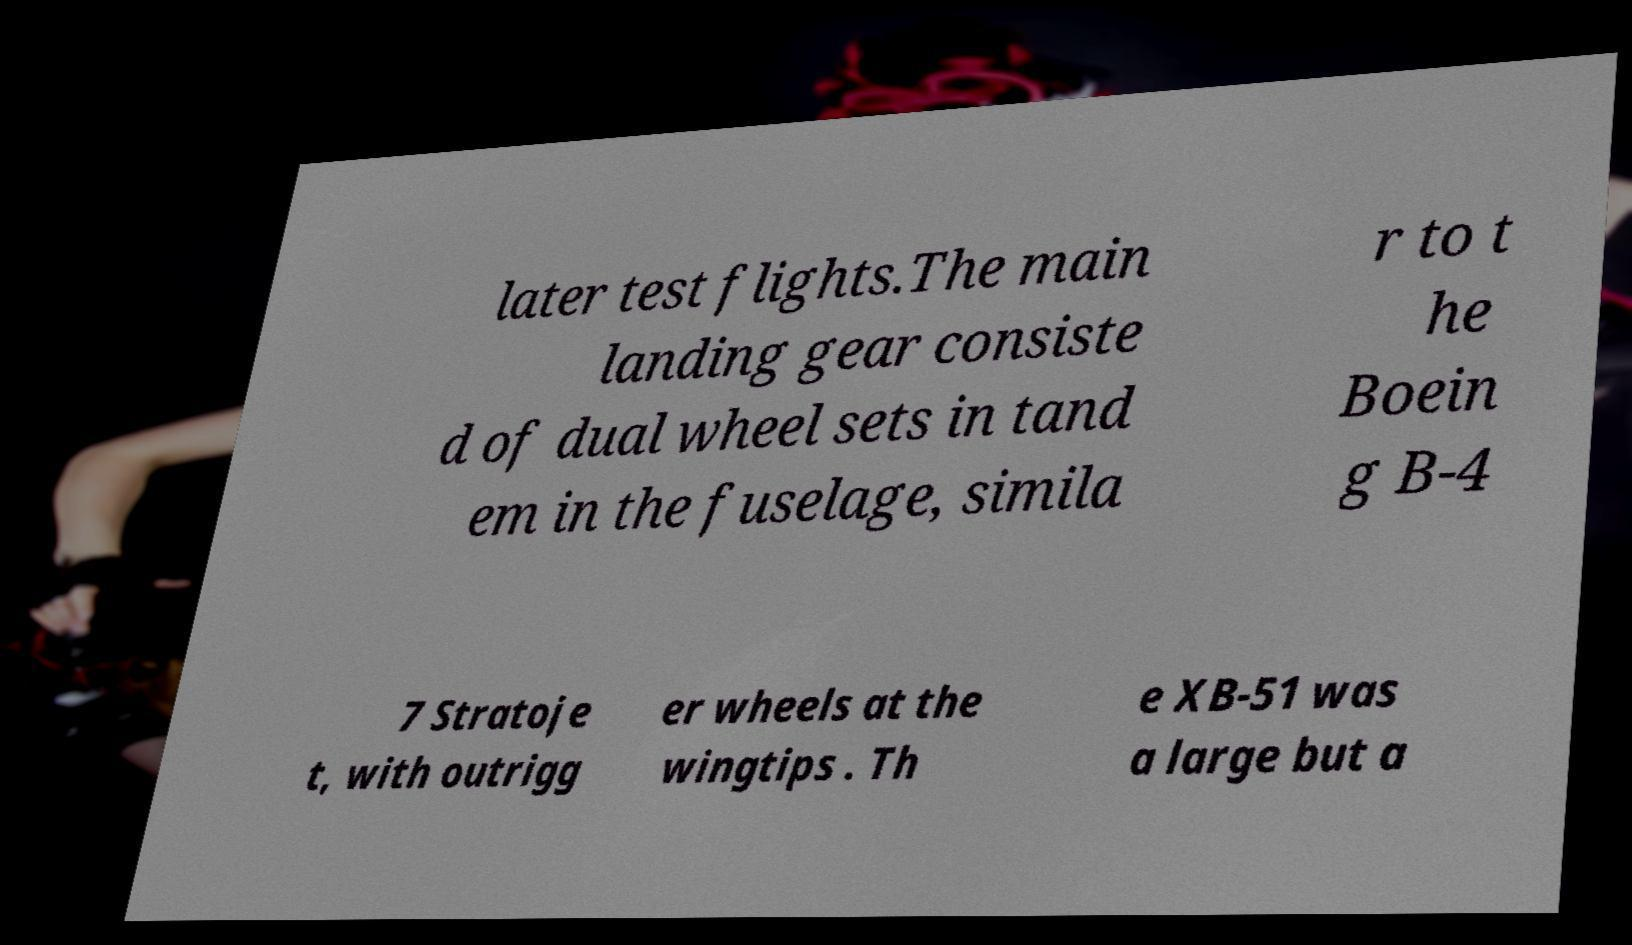Can you read and provide the text displayed in the image?This photo seems to have some interesting text. Can you extract and type it out for me? later test flights.The main landing gear consiste d of dual wheel sets in tand em in the fuselage, simila r to t he Boein g B-4 7 Stratoje t, with outrigg er wheels at the wingtips . Th e XB-51 was a large but a 